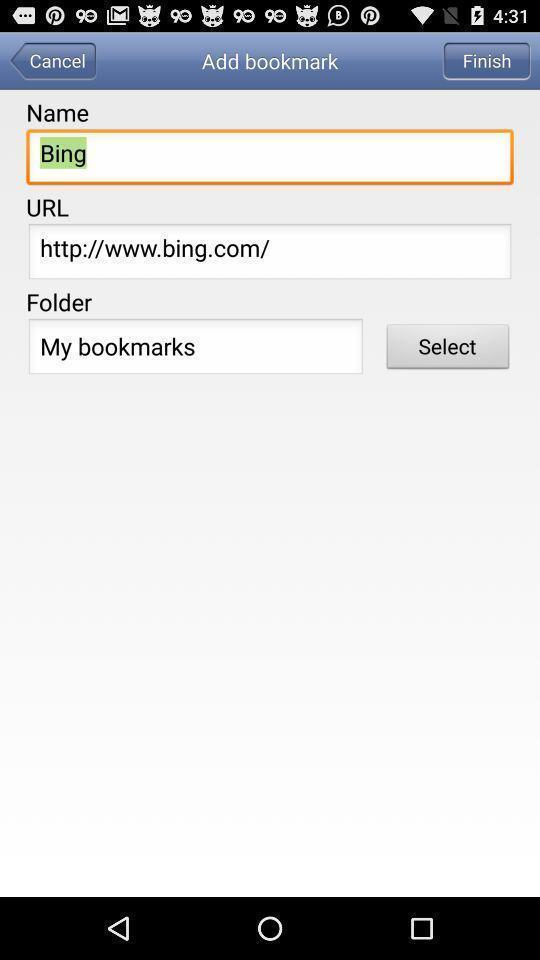Provide a description of this screenshot. Screen displaying adding a bookmark. 